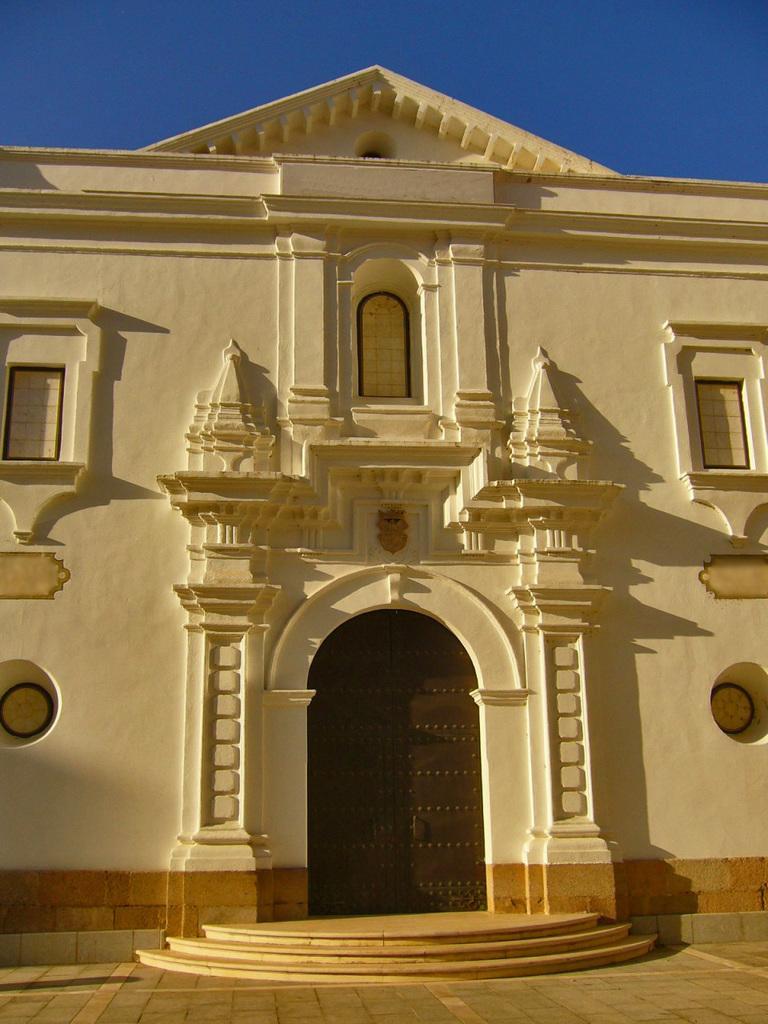How would you summarize this image in a sentence or two? In this image, we can see a building. We can see the ground and the sky. We can also see some stairs. 